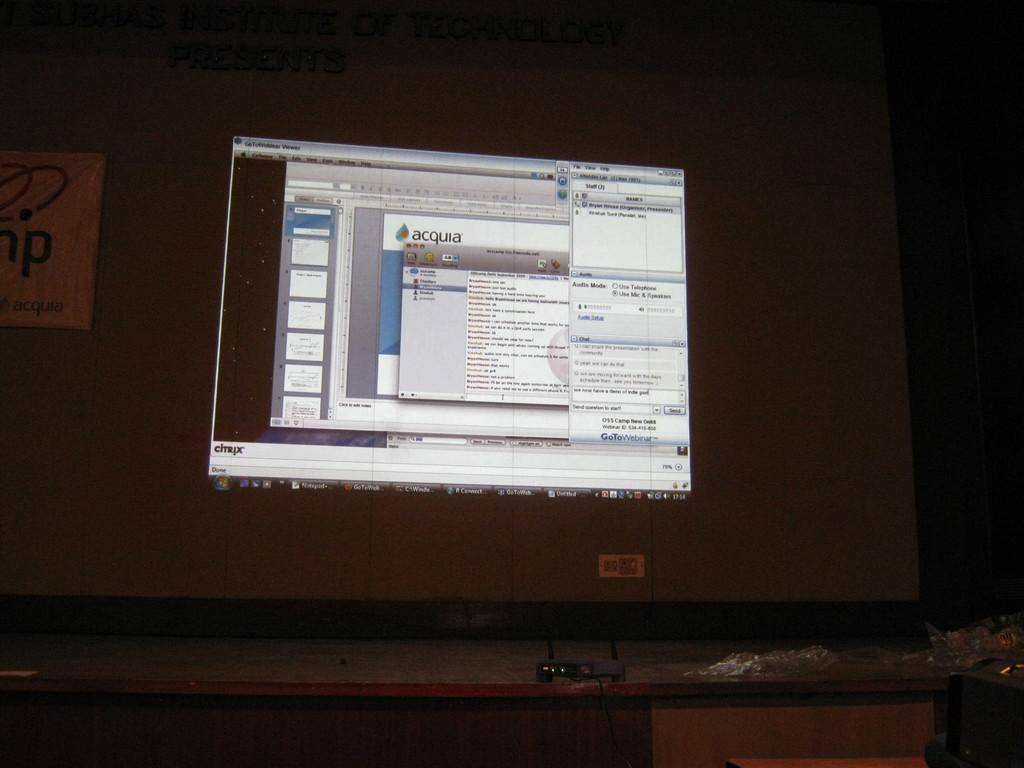<image>
Give a short and clear explanation of the subsequent image. A computer screen with several windows open has one window that says "acquia" at the top. 